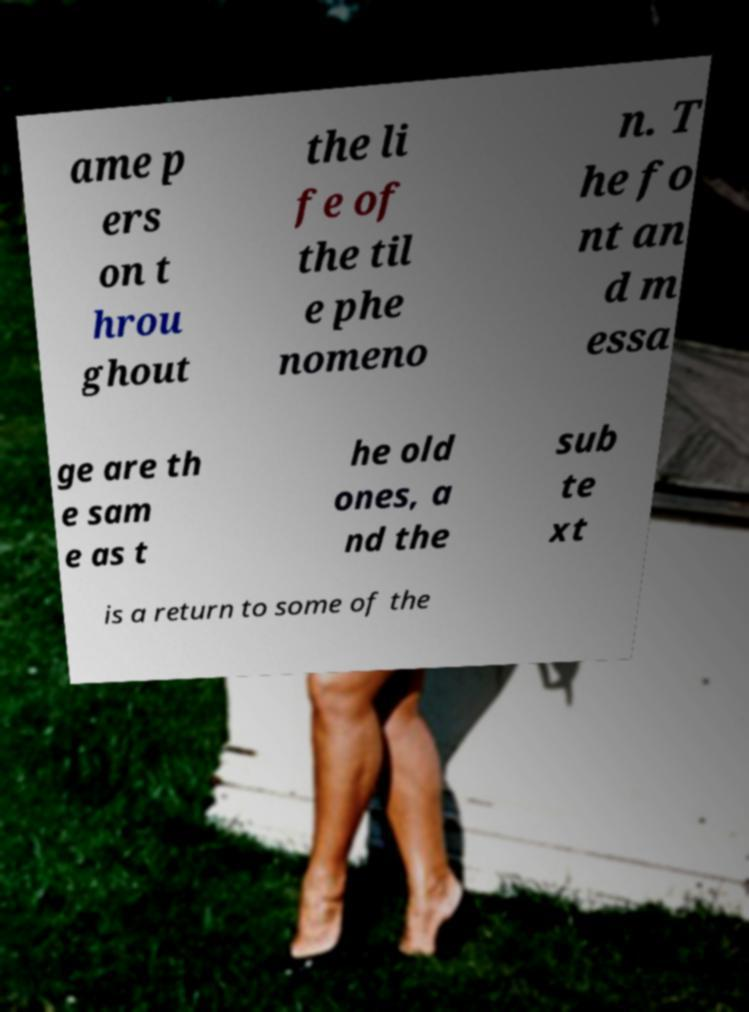Please identify and transcribe the text found in this image. ame p ers on t hrou ghout the li fe of the til e phe nomeno n. T he fo nt an d m essa ge are th e sam e as t he old ones, a nd the sub te xt is a return to some of the 